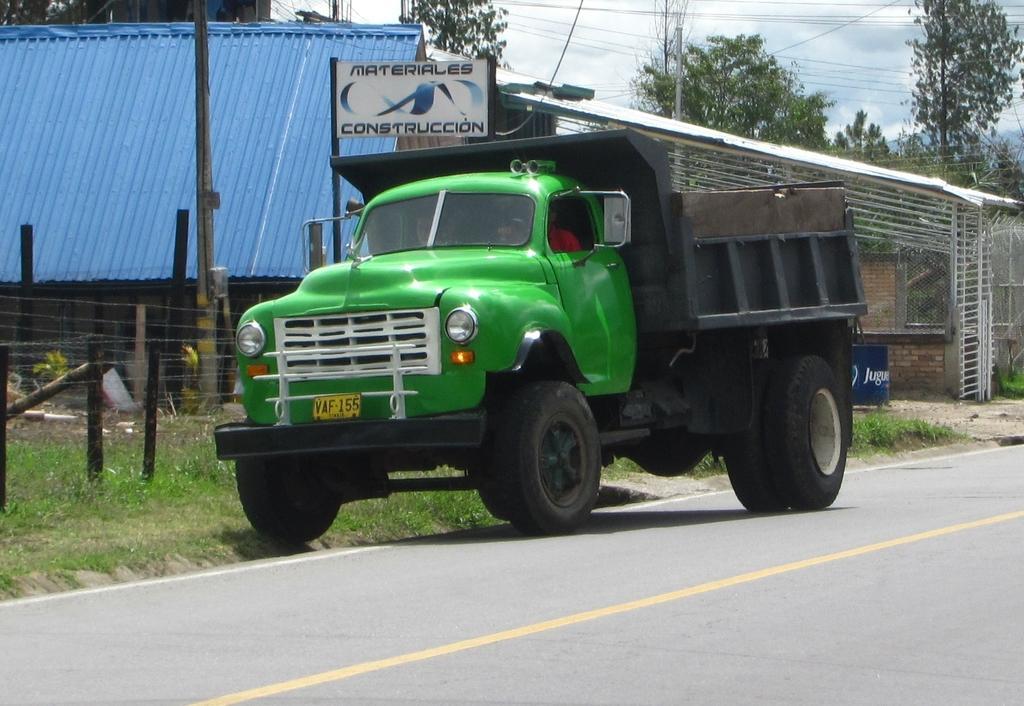Please provide a concise description of this image. In front of the image there is a vehicle on the road and there are two people sitting inside the vehicle. Behind the vehicle there are boards, poles. There is grass on the surface. There is a fence. There are electrical poles with cables. There is a metal shed. In the background of the image there are trees. At the top of the image there are clouds in the sky. 